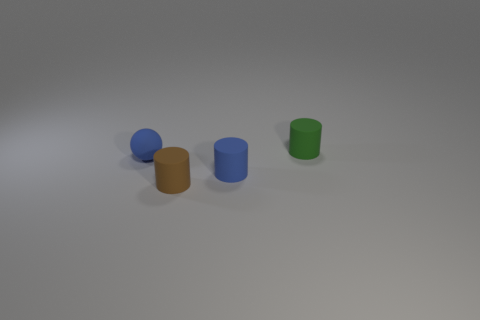Add 2 large metallic cylinders. How many objects exist? 6 Subtract all balls. How many objects are left? 3 Subtract all rubber cylinders. Subtract all big yellow matte cylinders. How many objects are left? 1 Add 2 tiny brown cylinders. How many tiny brown cylinders are left? 3 Add 4 small blue things. How many small blue things exist? 6 Subtract 0 blue blocks. How many objects are left? 4 